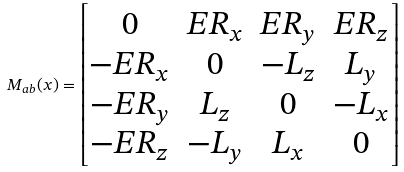Convert formula to latex. <formula><loc_0><loc_0><loc_500><loc_500>M _ { a b } ( x ) = \left [ \begin{matrix} 0 & E R _ { x } & E R _ { y } & E R _ { z } \\ - E R _ { x } & 0 & - L _ { z } & L _ { y } \\ - E R _ { y } & L _ { z } & 0 & - L _ { x } \\ - E R _ { z } & - L _ { y } & L _ { x } & 0 \end{matrix} \right ]</formula> 